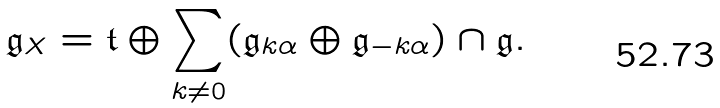Convert formula to latex. <formula><loc_0><loc_0><loc_500><loc_500>\mathfrak { g } _ { X } = \mathfrak { t } \oplus \sum _ { k \neq 0 } ( \mathfrak { g } _ { k \alpha } \oplus \mathfrak { g } _ { - k \alpha } ) \cap \mathfrak { g } .</formula> 